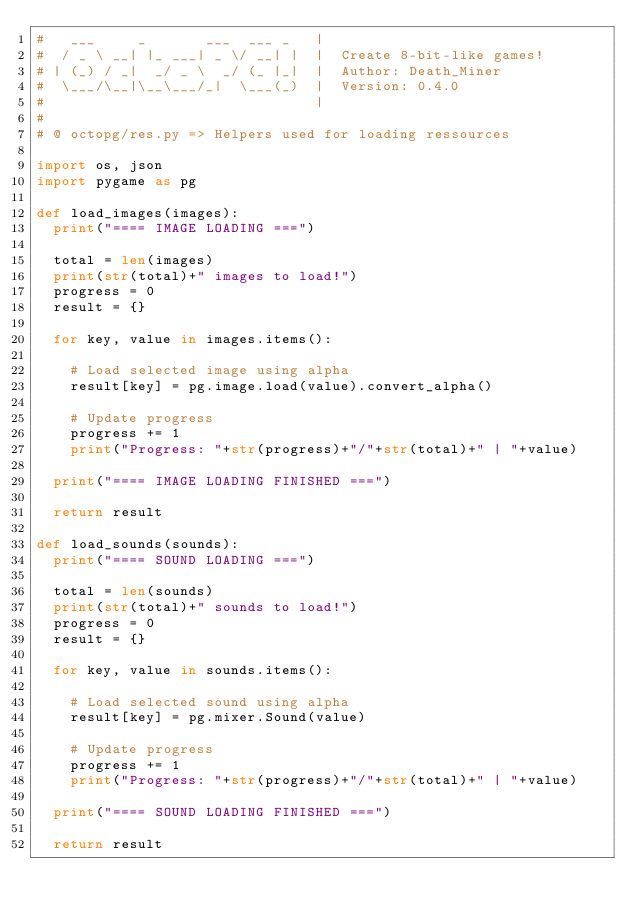Convert code to text. <code><loc_0><loc_0><loc_500><loc_500><_Python_>#   ___     _       ___  ___ _   |  
#  / _ \ __| |_ ___| _ \/ __| |  |  Create 8-bit-like games!
# | (_) / _|  _/ _ \  _/ (_ |_|  |  Author: Death_Miner
#  \___/\__|\__\___/_|  \___(_)  |  Version: 0.4.0
#                                |  
#
# @ octopg/res.py => Helpers used for loading ressources

import os, json
import pygame as pg

def load_images(images):
	print("==== IMAGE LOADING ===")

	total = len(images)
	print(str(total)+" images to load!")
	progress = 0
	result = {}

	for key, value in images.items():

		# Load selected image using alpha
		result[key] = pg.image.load(value).convert_alpha()

		# Update progress
		progress += 1
		print("Progress: "+str(progress)+"/"+str(total)+" | "+value)

	print("==== IMAGE LOADING FINISHED ===")

	return result

def load_sounds(sounds):
	print("==== SOUND LOADING ===")

	total = len(sounds)
	print(str(total)+" sounds to load!")
	progress = 0
	result = {}

	for key, value in sounds.items():

		# Load selected sound using alpha
		result[key] = pg.mixer.Sound(value)

		# Update progress
		progress += 1
		print("Progress: "+str(progress)+"/"+str(total)+" | "+value)

	print("==== SOUND LOADING FINISHED ===")

	return result</code> 